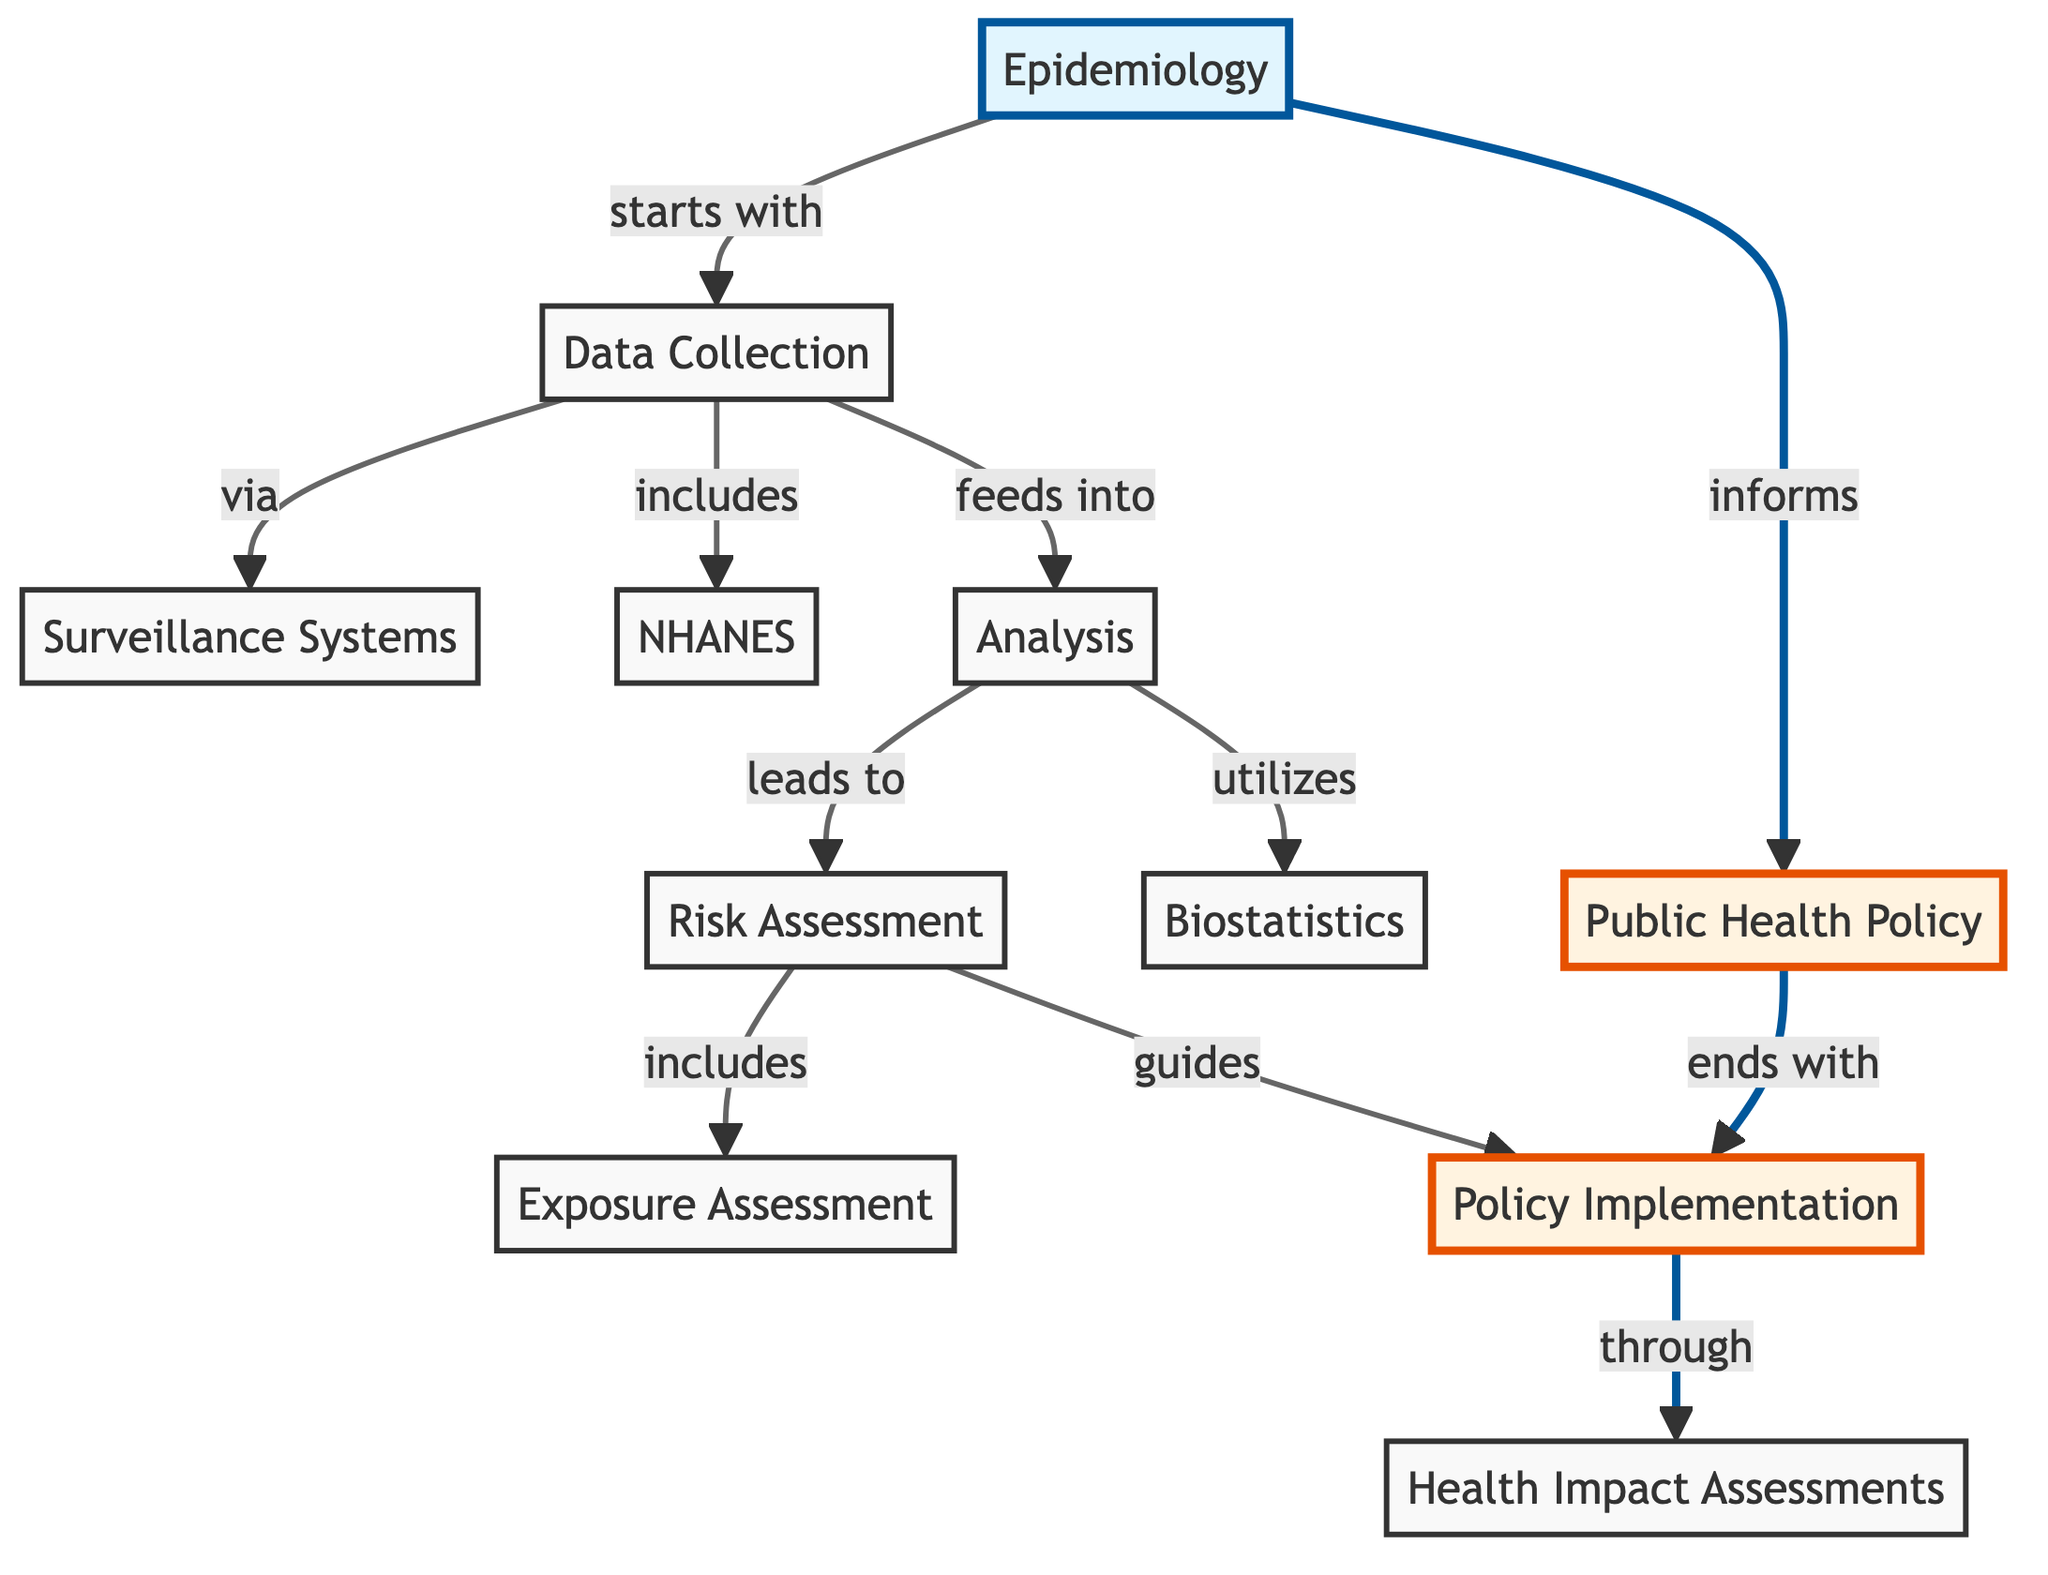What is the first step in the process represented in the diagram? The diagram indicates that the process starts with "Data Collection." This is the first node branching from the "Epidemiology" node, showing that it is the initial step in the flow of epidemiological processes that lead to public health policy.
Answer: Data Collection How many nodes are present in the diagram? By counting each unique labeled item in the diagram, we find there are 11 nodes listed, indicating various key terms associated with epidemiology and public health policy.
Answer: 11 What is the relationship between Epidemiology and Public Health Policy? According to the diagram, the relationship is that Epidemiology "informs" Public Health Policy. This implies that data and findings gathered from epidemiological practices play a foundational role in shaping health policies.
Answer: informs What follows after Analysis in the process? The diagram shows that after "Analysis," the next step is "Risk Assessment." This means that the output of the analysis phase directly leads into evaluating risks, crucial for understanding health outcomes.
Answer: Risk Assessment Which node is considered to guide Policy Implementation? The diagram states that "Risk Assessment" guides "Policy Implementation." This connection highlights the importance of assessing risks to shape effective health policies based on identified health risks and strategies.
Answer: Policy Implementation What is included in the Data Collection phase? The "Data Collection" phase includes both "Surveillance Systems" and "National Health and Nutrition Examination Survey (NHANES)" as indicated by their direct connections to the Data Collection node. This means these are key components for gathering relevant data.
Answer: Surveillance Systems, National Health and Nutrition Examination Survey (NHANES) Which node leads to Health Impact Assessments in the process? The diagram clearly indicates that "Policy Implementation" leads to "Health Impact Assessments." This means after policies are implemented, health impact assessments are conducted to evaluate the effects of those policies.
Answer: Health Impact Assessments What two practices does Analysis utilize according to the diagram? The diagram specifies that "Analysis" utilizes "Biostatistics." This indicates that statistical methods are fundamental to the analysis phase in interpreting epidemiological data.
Answer: Biostatistics How does Exposure Assessment fit within the Risk Assessment? The diagram shows that "Exposure Assessment" is included in the node of "Risk Assessment," meaning it is a crucial factor considered when assessing overall risks related to health.
Answer: Exposure Assessment 